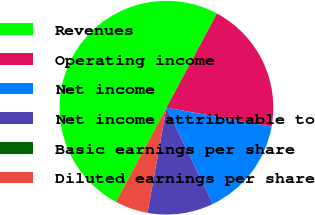Convert chart. <chart><loc_0><loc_0><loc_500><loc_500><pie_chart><fcel>Revenues<fcel>Operating income<fcel>Net income<fcel>Net income attributable to<fcel>Basic earnings per share<fcel>Diluted earnings per share<nl><fcel>50.0%<fcel>20.0%<fcel>15.0%<fcel>10.0%<fcel>0.0%<fcel>5.0%<nl></chart> 